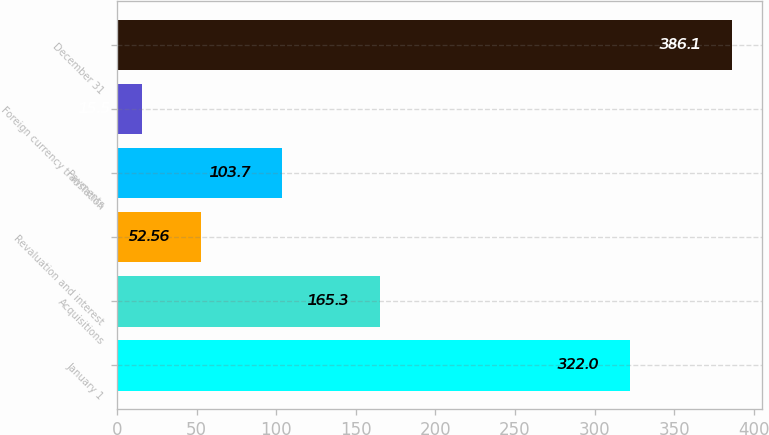Convert chart. <chart><loc_0><loc_0><loc_500><loc_500><bar_chart><fcel>January 1<fcel>Acquisitions<fcel>Revaluation and interest<fcel>Payments<fcel>Foreign currency translation<fcel>December 31<nl><fcel>322<fcel>165.3<fcel>52.56<fcel>103.7<fcel>15.5<fcel>386.1<nl></chart> 